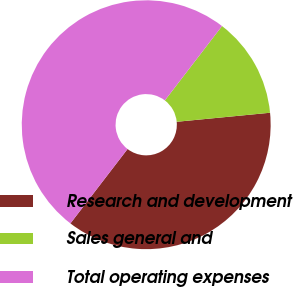Convert chart to OTSL. <chart><loc_0><loc_0><loc_500><loc_500><pie_chart><fcel>Research and development<fcel>Sales general and<fcel>Total operating expenses<nl><fcel>36.96%<fcel>13.04%<fcel>50.0%<nl></chart> 